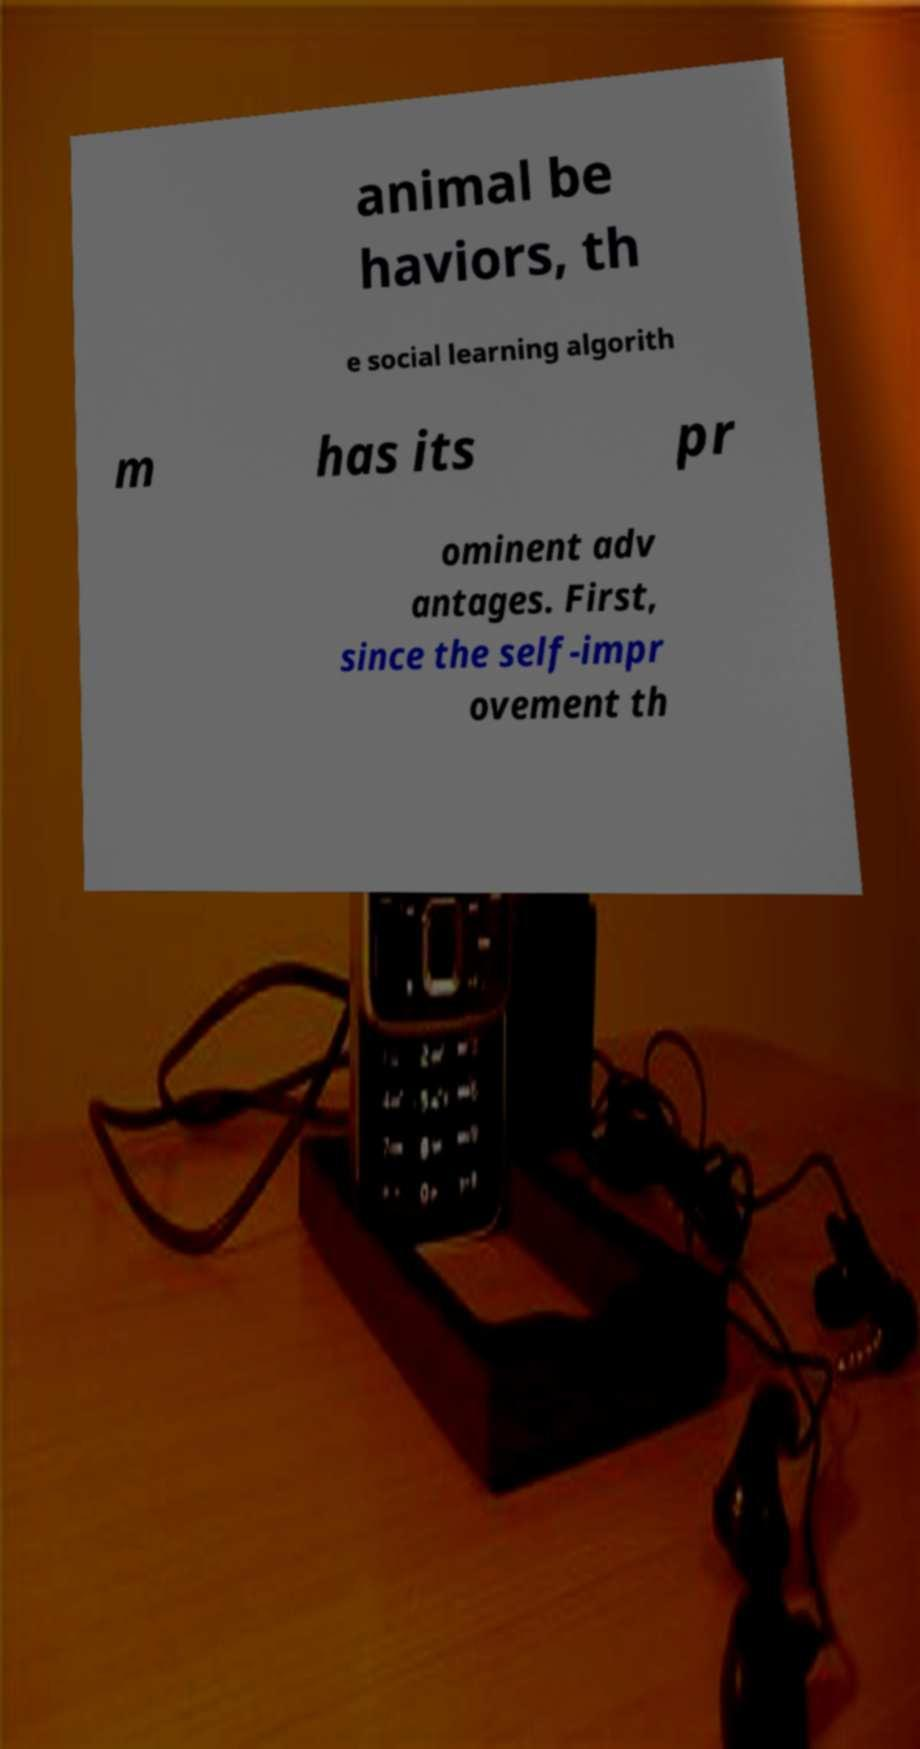For documentation purposes, I need the text within this image transcribed. Could you provide that? animal be haviors, th e social learning algorith m has its pr ominent adv antages. First, since the self-impr ovement th 